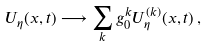<formula> <loc_0><loc_0><loc_500><loc_500>U _ { \eta } ( x , t ) \longrightarrow \sum _ { k } g _ { 0 } ^ { k } U _ { \eta } ^ { ( k ) } ( x , t ) \, ,</formula> 